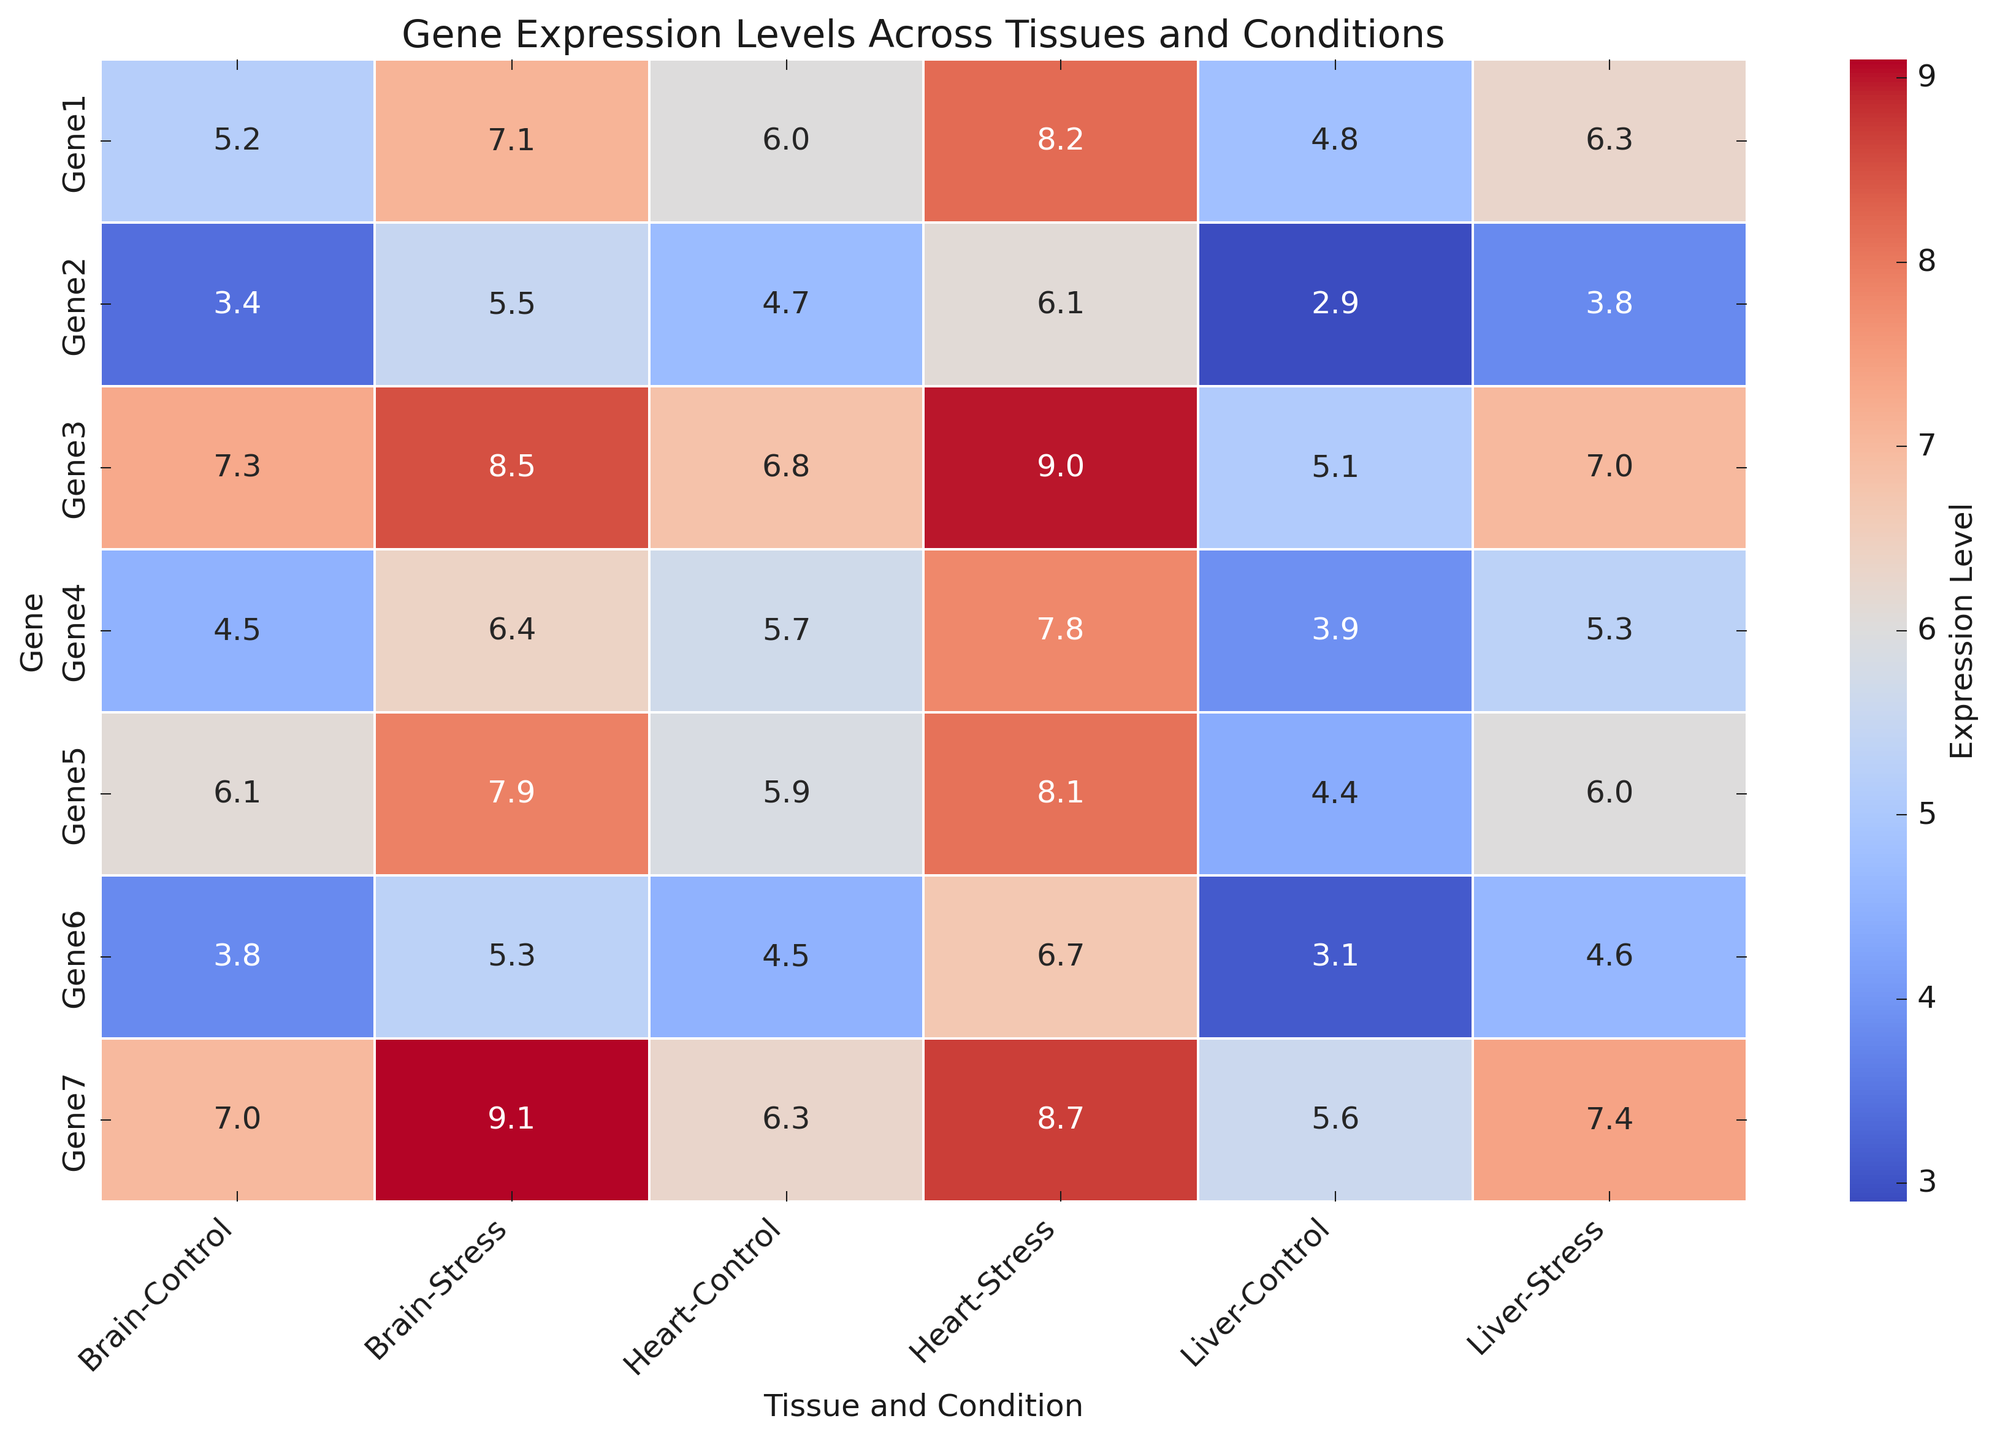What tissue and condition combination shows the highest expression level for Gene1? Look for the highest number in the row corresponding to Gene1. This value is 8.2 and it appears in the column for Heart under the Stress condition.
Answer: Heart under Stress Which gene has the lowest expression level in the Liver under the Control condition? Identify the column corresponding to Liver under the Control condition and find the minimum value. This value is 2.9 and it corresponds to Gene2.
Answer: Gene2 What is the average expression level for Gene3 across all tissues and conditions? Sum the expression levels for Gene3 (7.3, 8.5, 5.1, 7.0, 6.8, 9.0) and divide by the number of entries. The calculation is (7.3 + 8.5 + 5.1 + 7.0 + 6.8 + 9.0) / 6 = 43.7 / 6 = 7.28.
Answer: 7.28 Which gene shows the most significant increase in expression levels in the Brain tissue under Stress condition compared to Control? Compute the difference between Stress and Control expression levels for each gene in the Brain tissue. The differences are: Gene1 (7.1 - 5.2 = 1.9), Gene2 (5.5 - 3.4 = 2.1), Gene3 (8.5 - 7.3 = 1.2), Gene4 (6.4 - 4.5 = 1.9), Gene5 (7.9 - 6.1 = 1.8), Gene6 (5.3 - 3.8 = 1.5), Gene7 (9.1 - 7.0 = 2.1). Genes 2 and 7 both show the highest increase of 2.1.
Answer: Gene2 and Gene7 Which tissue type under Control condition consistently shows higher expressions across most genes? Compare the expression levels in the Control condition columns across all tissues. Brain (Gene1: 5.2, Gene2: 3.4, Gene3: 7.3, Gene4: 4.5, Gene5: 6.1, Gene6: 3.8, Gene7: 7.0), Liver (Gene1: 4.8, Gene2: 2.9, Gene3: 5.1, Gene4: 3.9, Gene5: 4.4, Gene6: 3.1, Gene7: 5.6), Heart (Gene1: 6.0, Gene2: 4.7, Gene3: 6.8, Gene4: 5.7, Gene5: 5.9, Gene6: 4.5, Gene7: 6.3). Brain shows higher expression levels in more cases.
Answer: Brain What is the median expression level of Gene4 across all conditions and tissues? List the expression levels for Gene4 (4.5, 6.4, 3.9, 5.3, 5.7, 7.8) and find the median. Arranging them from smallest to largest (3.9, 4.5, 5.3, 5.7, 6.4, 7.8), the median is the average of the two middle numbers: (5.3 + 5.7) / 2 = 5.5.
Answer: 5.5 In which tissue and condition is the expression level for Gene7 the most elevated? For Gene7, look for the highest value among all tissues and conditions. The values are: Brain - Control (7.0), Brain - Stress (9.1), Liver - Control (5.6), Liver - Stress (7.4), Heart - Control (6.3), Heart - Stress (8.7). The highest value is 9.1 in Brain under Stress condition.
Answer: Brain under Stress 